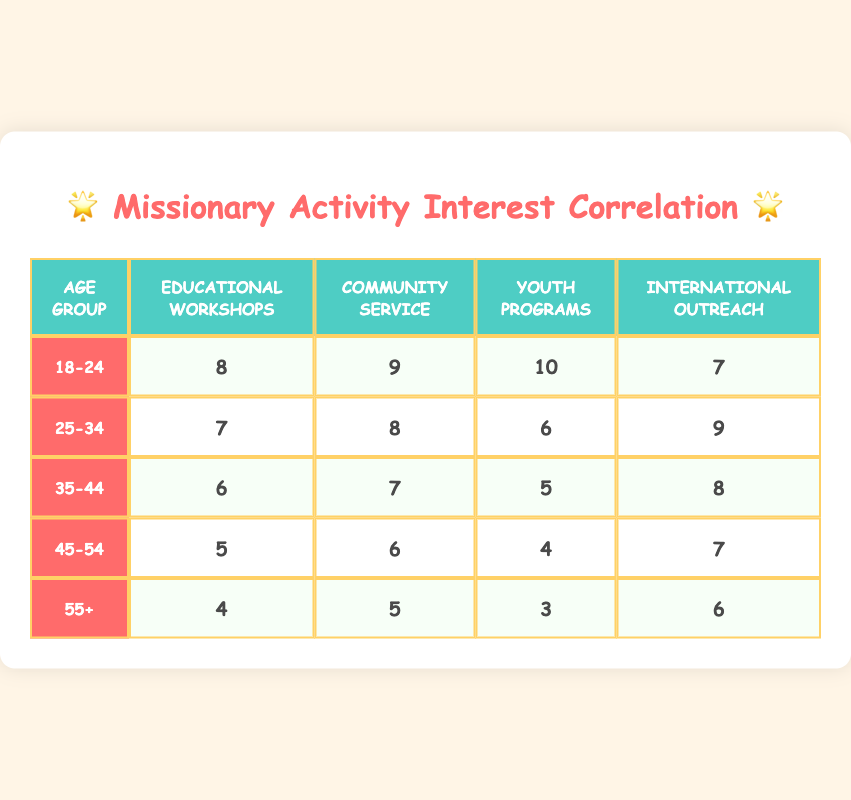What is the interest level for Youth Programs among the 18-24 age group? Referring to the table, the interest level for Youth Programs in the 18-24 age group is directly provided as 10.
Answer: 10 Which age group shows the highest interest in Community Service? The table lists the interest levels for Community Service across all age groups. The highest value is 9 from the 18-24 age group.
Answer: 18-24 What is the average interest level in International Outreach across all age groups? To find the average for International Outreach, add the interest levels: (7 + 9 + 8 + 7 + 6) = 37. There are 5 age groups, so the average is 37/5 = 7.4.
Answer: 7.4 Is the interest level for Educational Workshops higher in the 25-34 age group than in the 35-44 age group? The interest level for Educational Workshops in the 25-34 age group is 7, while in the 35-44 age group, it is 6. Since 7 is greater than 6, the statement is true.
Answer: Yes Which age group has the lowest overall interest in missionary activities? To determine the lowest overall interest, we look at the average of the interest levels for each age group. The averages are: 8.5 for 18-24, 7.5 for 25-34, 6.5 for 35-44, 5.5 for 45-54, and 4.5 for 55+. The 55+ age group has the lowest average of 4.5.
Answer: 55+ 